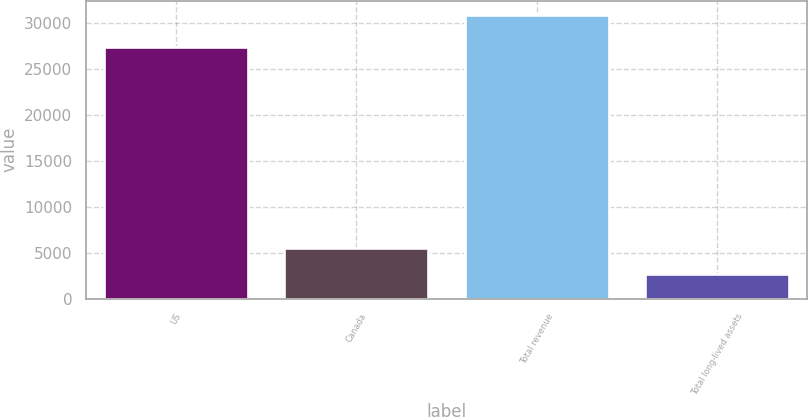<chart> <loc_0><loc_0><loc_500><loc_500><bar_chart><fcel>US<fcel>Canada<fcel>Total revenue<fcel>Total long-lived assets<nl><fcel>27380<fcel>5525.6<fcel>30848<fcel>2712<nl></chart> 